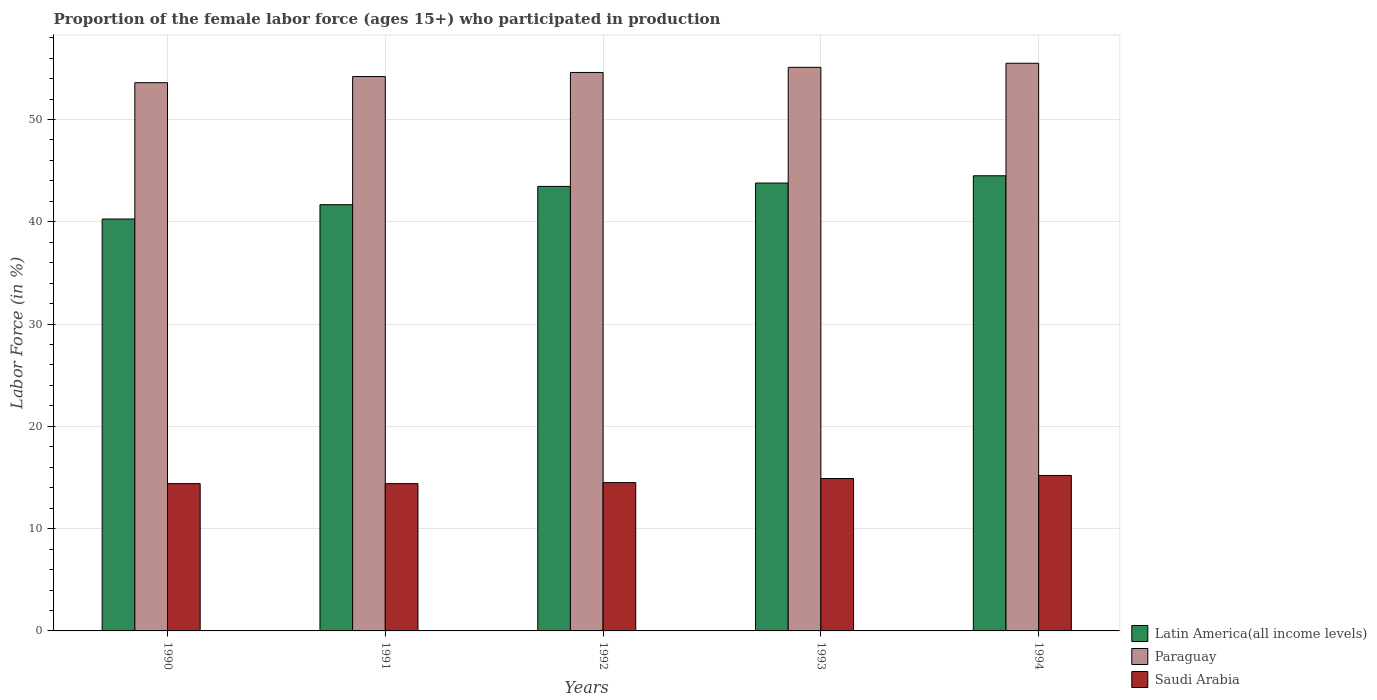How many groups of bars are there?
Provide a succinct answer. 5. Are the number of bars per tick equal to the number of legend labels?
Keep it short and to the point. Yes. Are the number of bars on each tick of the X-axis equal?
Provide a short and direct response. Yes. How many bars are there on the 3rd tick from the left?
Offer a terse response. 3. In how many cases, is the number of bars for a given year not equal to the number of legend labels?
Keep it short and to the point. 0. What is the proportion of the female labor force who participated in production in Latin America(all income levels) in 1991?
Your answer should be very brief. 41.67. Across all years, what is the maximum proportion of the female labor force who participated in production in Latin America(all income levels)?
Provide a short and direct response. 44.5. Across all years, what is the minimum proportion of the female labor force who participated in production in Saudi Arabia?
Ensure brevity in your answer.  14.4. In which year was the proportion of the female labor force who participated in production in Paraguay minimum?
Your answer should be very brief. 1990. What is the total proportion of the female labor force who participated in production in Paraguay in the graph?
Your answer should be compact. 273. What is the difference between the proportion of the female labor force who participated in production in Saudi Arabia in 1992 and the proportion of the female labor force who participated in production in Paraguay in 1991?
Your answer should be very brief. -39.7. What is the average proportion of the female labor force who participated in production in Saudi Arabia per year?
Offer a very short reply. 14.68. In the year 1993, what is the difference between the proportion of the female labor force who participated in production in Latin America(all income levels) and proportion of the female labor force who participated in production in Paraguay?
Give a very brief answer. -11.31. In how many years, is the proportion of the female labor force who participated in production in Paraguay greater than 46 %?
Provide a short and direct response. 5. What is the ratio of the proportion of the female labor force who participated in production in Paraguay in 1990 to that in 1994?
Offer a very short reply. 0.97. What is the difference between the highest and the second highest proportion of the female labor force who participated in production in Paraguay?
Ensure brevity in your answer.  0.4. What is the difference between the highest and the lowest proportion of the female labor force who participated in production in Paraguay?
Give a very brief answer. 1.9. Is the sum of the proportion of the female labor force who participated in production in Latin America(all income levels) in 1992 and 1994 greater than the maximum proportion of the female labor force who participated in production in Paraguay across all years?
Provide a short and direct response. Yes. What does the 1st bar from the left in 1993 represents?
Give a very brief answer. Latin America(all income levels). What does the 1st bar from the right in 1994 represents?
Provide a succinct answer. Saudi Arabia. How many bars are there?
Your answer should be very brief. 15. How many years are there in the graph?
Your response must be concise. 5. What is the difference between two consecutive major ticks on the Y-axis?
Keep it short and to the point. 10. Are the values on the major ticks of Y-axis written in scientific E-notation?
Offer a very short reply. No. Does the graph contain grids?
Offer a very short reply. Yes. Where does the legend appear in the graph?
Your answer should be compact. Bottom right. What is the title of the graph?
Ensure brevity in your answer.  Proportion of the female labor force (ages 15+) who participated in production. Does "United States" appear as one of the legend labels in the graph?
Offer a very short reply. No. What is the Labor Force (in %) of Latin America(all income levels) in 1990?
Ensure brevity in your answer.  40.27. What is the Labor Force (in %) of Paraguay in 1990?
Give a very brief answer. 53.6. What is the Labor Force (in %) in Saudi Arabia in 1990?
Provide a short and direct response. 14.4. What is the Labor Force (in %) of Latin America(all income levels) in 1991?
Your response must be concise. 41.67. What is the Labor Force (in %) in Paraguay in 1991?
Give a very brief answer. 54.2. What is the Labor Force (in %) in Saudi Arabia in 1991?
Your answer should be very brief. 14.4. What is the Labor Force (in %) in Latin America(all income levels) in 1992?
Keep it short and to the point. 43.46. What is the Labor Force (in %) in Paraguay in 1992?
Give a very brief answer. 54.6. What is the Labor Force (in %) of Saudi Arabia in 1992?
Keep it short and to the point. 14.5. What is the Labor Force (in %) in Latin America(all income levels) in 1993?
Keep it short and to the point. 43.79. What is the Labor Force (in %) in Paraguay in 1993?
Your response must be concise. 55.1. What is the Labor Force (in %) in Saudi Arabia in 1993?
Your answer should be compact. 14.9. What is the Labor Force (in %) in Latin America(all income levels) in 1994?
Offer a terse response. 44.5. What is the Labor Force (in %) of Paraguay in 1994?
Provide a succinct answer. 55.5. What is the Labor Force (in %) of Saudi Arabia in 1994?
Provide a succinct answer. 15.2. Across all years, what is the maximum Labor Force (in %) in Latin America(all income levels)?
Offer a terse response. 44.5. Across all years, what is the maximum Labor Force (in %) of Paraguay?
Your response must be concise. 55.5. Across all years, what is the maximum Labor Force (in %) of Saudi Arabia?
Your answer should be compact. 15.2. Across all years, what is the minimum Labor Force (in %) in Latin America(all income levels)?
Provide a succinct answer. 40.27. Across all years, what is the minimum Labor Force (in %) in Paraguay?
Make the answer very short. 53.6. Across all years, what is the minimum Labor Force (in %) of Saudi Arabia?
Your answer should be compact. 14.4. What is the total Labor Force (in %) in Latin America(all income levels) in the graph?
Make the answer very short. 213.69. What is the total Labor Force (in %) in Paraguay in the graph?
Keep it short and to the point. 273. What is the total Labor Force (in %) in Saudi Arabia in the graph?
Ensure brevity in your answer.  73.4. What is the difference between the Labor Force (in %) of Latin America(all income levels) in 1990 and that in 1991?
Make the answer very short. -1.4. What is the difference between the Labor Force (in %) of Latin America(all income levels) in 1990 and that in 1992?
Your answer should be compact. -3.19. What is the difference between the Labor Force (in %) of Paraguay in 1990 and that in 1992?
Your response must be concise. -1. What is the difference between the Labor Force (in %) in Latin America(all income levels) in 1990 and that in 1993?
Make the answer very short. -3.52. What is the difference between the Labor Force (in %) in Paraguay in 1990 and that in 1993?
Keep it short and to the point. -1.5. What is the difference between the Labor Force (in %) in Latin America(all income levels) in 1990 and that in 1994?
Provide a succinct answer. -4.23. What is the difference between the Labor Force (in %) in Latin America(all income levels) in 1991 and that in 1992?
Provide a short and direct response. -1.79. What is the difference between the Labor Force (in %) of Saudi Arabia in 1991 and that in 1992?
Make the answer very short. -0.1. What is the difference between the Labor Force (in %) of Latin America(all income levels) in 1991 and that in 1993?
Your answer should be compact. -2.12. What is the difference between the Labor Force (in %) in Paraguay in 1991 and that in 1993?
Offer a terse response. -0.9. What is the difference between the Labor Force (in %) of Saudi Arabia in 1991 and that in 1993?
Your response must be concise. -0.5. What is the difference between the Labor Force (in %) in Latin America(all income levels) in 1991 and that in 1994?
Provide a succinct answer. -2.83. What is the difference between the Labor Force (in %) of Saudi Arabia in 1991 and that in 1994?
Offer a very short reply. -0.8. What is the difference between the Labor Force (in %) of Latin America(all income levels) in 1992 and that in 1993?
Your response must be concise. -0.33. What is the difference between the Labor Force (in %) in Saudi Arabia in 1992 and that in 1993?
Keep it short and to the point. -0.4. What is the difference between the Labor Force (in %) in Latin America(all income levels) in 1992 and that in 1994?
Your response must be concise. -1.04. What is the difference between the Labor Force (in %) in Paraguay in 1992 and that in 1994?
Your response must be concise. -0.9. What is the difference between the Labor Force (in %) in Saudi Arabia in 1992 and that in 1994?
Keep it short and to the point. -0.7. What is the difference between the Labor Force (in %) of Latin America(all income levels) in 1993 and that in 1994?
Ensure brevity in your answer.  -0.71. What is the difference between the Labor Force (in %) of Paraguay in 1993 and that in 1994?
Give a very brief answer. -0.4. What is the difference between the Labor Force (in %) in Latin America(all income levels) in 1990 and the Labor Force (in %) in Paraguay in 1991?
Keep it short and to the point. -13.93. What is the difference between the Labor Force (in %) in Latin America(all income levels) in 1990 and the Labor Force (in %) in Saudi Arabia in 1991?
Your answer should be compact. 25.87. What is the difference between the Labor Force (in %) in Paraguay in 1990 and the Labor Force (in %) in Saudi Arabia in 1991?
Make the answer very short. 39.2. What is the difference between the Labor Force (in %) of Latin America(all income levels) in 1990 and the Labor Force (in %) of Paraguay in 1992?
Make the answer very short. -14.33. What is the difference between the Labor Force (in %) in Latin America(all income levels) in 1990 and the Labor Force (in %) in Saudi Arabia in 1992?
Ensure brevity in your answer.  25.77. What is the difference between the Labor Force (in %) of Paraguay in 1990 and the Labor Force (in %) of Saudi Arabia in 1992?
Keep it short and to the point. 39.1. What is the difference between the Labor Force (in %) of Latin America(all income levels) in 1990 and the Labor Force (in %) of Paraguay in 1993?
Your response must be concise. -14.83. What is the difference between the Labor Force (in %) of Latin America(all income levels) in 1990 and the Labor Force (in %) of Saudi Arabia in 1993?
Your answer should be compact. 25.37. What is the difference between the Labor Force (in %) of Paraguay in 1990 and the Labor Force (in %) of Saudi Arabia in 1993?
Give a very brief answer. 38.7. What is the difference between the Labor Force (in %) of Latin America(all income levels) in 1990 and the Labor Force (in %) of Paraguay in 1994?
Offer a terse response. -15.23. What is the difference between the Labor Force (in %) of Latin America(all income levels) in 1990 and the Labor Force (in %) of Saudi Arabia in 1994?
Provide a succinct answer. 25.07. What is the difference between the Labor Force (in %) of Paraguay in 1990 and the Labor Force (in %) of Saudi Arabia in 1994?
Offer a very short reply. 38.4. What is the difference between the Labor Force (in %) in Latin America(all income levels) in 1991 and the Labor Force (in %) in Paraguay in 1992?
Give a very brief answer. -12.93. What is the difference between the Labor Force (in %) of Latin America(all income levels) in 1991 and the Labor Force (in %) of Saudi Arabia in 1992?
Offer a terse response. 27.17. What is the difference between the Labor Force (in %) in Paraguay in 1991 and the Labor Force (in %) in Saudi Arabia in 1992?
Keep it short and to the point. 39.7. What is the difference between the Labor Force (in %) in Latin America(all income levels) in 1991 and the Labor Force (in %) in Paraguay in 1993?
Make the answer very short. -13.43. What is the difference between the Labor Force (in %) of Latin America(all income levels) in 1991 and the Labor Force (in %) of Saudi Arabia in 1993?
Keep it short and to the point. 26.77. What is the difference between the Labor Force (in %) of Paraguay in 1991 and the Labor Force (in %) of Saudi Arabia in 1993?
Make the answer very short. 39.3. What is the difference between the Labor Force (in %) of Latin America(all income levels) in 1991 and the Labor Force (in %) of Paraguay in 1994?
Your answer should be compact. -13.83. What is the difference between the Labor Force (in %) in Latin America(all income levels) in 1991 and the Labor Force (in %) in Saudi Arabia in 1994?
Make the answer very short. 26.47. What is the difference between the Labor Force (in %) in Paraguay in 1991 and the Labor Force (in %) in Saudi Arabia in 1994?
Provide a succinct answer. 39. What is the difference between the Labor Force (in %) of Latin America(all income levels) in 1992 and the Labor Force (in %) of Paraguay in 1993?
Make the answer very short. -11.64. What is the difference between the Labor Force (in %) in Latin America(all income levels) in 1992 and the Labor Force (in %) in Saudi Arabia in 1993?
Keep it short and to the point. 28.56. What is the difference between the Labor Force (in %) of Paraguay in 1992 and the Labor Force (in %) of Saudi Arabia in 1993?
Your answer should be compact. 39.7. What is the difference between the Labor Force (in %) of Latin America(all income levels) in 1992 and the Labor Force (in %) of Paraguay in 1994?
Your response must be concise. -12.04. What is the difference between the Labor Force (in %) of Latin America(all income levels) in 1992 and the Labor Force (in %) of Saudi Arabia in 1994?
Offer a terse response. 28.26. What is the difference between the Labor Force (in %) of Paraguay in 1992 and the Labor Force (in %) of Saudi Arabia in 1994?
Keep it short and to the point. 39.4. What is the difference between the Labor Force (in %) of Latin America(all income levels) in 1993 and the Labor Force (in %) of Paraguay in 1994?
Provide a short and direct response. -11.71. What is the difference between the Labor Force (in %) in Latin America(all income levels) in 1993 and the Labor Force (in %) in Saudi Arabia in 1994?
Ensure brevity in your answer.  28.59. What is the difference between the Labor Force (in %) of Paraguay in 1993 and the Labor Force (in %) of Saudi Arabia in 1994?
Ensure brevity in your answer.  39.9. What is the average Labor Force (in %) in Latin America(all income levels) per year?
Provide a succinct answer. 42.74. What is the average Labor Force (in %) of Paraguay per year?
Keep it short and to the point. 54.6. What is the average Labor Force (in %) of Saudi Arabia per year?
Offer a very short reply. 14.68. In the year 1990, what is the difference between the Labor Force (in %) of Latin America(all income levels) and Labor Force (in %) of Paraguay?
Ensure brevity in your answer.  -13.33. In the year 1990, what is the difference between the Labor Force (in %) in Latin America(all income levels) and Labor Force (in %) in Saudi Arabia?
Give a very brief answer. 25.87. In the year 1990, what is the difference between the Labor Force (in %) of Paraguay and Labor Force (in %) of Saudi Arabia?
Offer a terse response. 39.2. In the year 1991, what is the difference between the Labor Force (in %) in Latin America(all income levels) and Labor Force (in %) in Paraguay?
Your answer should be compact. -12.53. In the year 1991, what is the difference between the Labor Force (in %) in Latin America(all income levels) and Labor Force (in %) in Saudi Arabia?
Provide a short and direct response. 27.27. In the year 1991, what is the difference between the Labor Force (in %) of Paraguay and Labor Force (in %) of Saudi Arabia?
Provide a short and direct response. 39.8. In the year 1992, what is the difference between the Labor Force (in %) of Latin America(all income levels) and Labor Force (in %) of Paraguay?
Your answer should be very brief. -11.14. In the year 1992, what is the difference between the Labor Force (in %) in Latin America(all income levels) and Labor Force (in %) in Saudi Arabia?
Offer a very short reply. 28.96. In the year 1992, what is the difference between the Labor Force (in %) in Paraguay and Labor Force (in %) in Saudi Arabia?
Your answer should be very brief. 40.1. In the year 1993, what is the difference between the Labor Force (in %) in Latin America(all income levels) and Labor Force (in %) in Paraguay?
Give a very brief answer. -11.31. In the year 1993, what is the difference between the Labor Force (in %) in Latin America(all income levels) and Labor Force (in %) in Saudi Arabia?
Your answer should be very brief. 28.89. In the year 1993, what is the difference between the Labor Force (in %) of Paraguay and Labor Force (in %) of Saudi Arabia?
Your response must be concise. 40.2. In the year 1994, what is the difference between the Labor Force (in %) of Latin America(all income levels) and Labor Force (in %) of Paraguay?
Offer a terse response. -11. In the year 1994, what is the difference between the Labor Force (in %) in Latin America(all income levels) and Labor Force (in %) in Saudi Arabia?
Provide a short and direct response. 29.3. In the year 1994, what is the difference between the Labor Force (in %) in Paraguay and Labor Force (in %) in Saudi Arabia?
Offer a very short reply. 40.3. What is the ratio of the Labor Force (in %) of Latin America(all income levels) in 1990 to that in 1991?
Ensure brevity in your answer.  0.97. What is the ratio of the Labor Force (in %) in Paraguay in 1990 to that in 1991?
Your response must be concise. 0.99. What is the ratio of the Labor Force (in %) in Latin America(all income levels) in 1990 to that in 1992?
Your answer should be very brief. 0.93. What is the ratio of the Labor Force (in %) in Paraguay in 1990 to that in 1992?
Give a very brief answer. 0.98. What is the ratio of the Labor Force (in %) in Saudi Arabia in 1990 to that in 1992?
Your response must be concise. 0.99. What is the ratio of the Labor Force (in %) of Latin America(all income levels) in 1990 to that in 1993?
Your answer should be compact. 0.92. What is the ratio of the Labor Force (in %) of Paraguay in 1990 to that in 1993?
Provide a succinct answer. 0.97. What is the ratio of the Labor Force (in %) of Saudi Arabia in 1990 to that in 1993?
Ensure brevity in your answer.  0.97. What is the ratio of the Labor Force (in %) in Latin America(all income levels) in 1990 to that in 1994?
Your answer should be very brief. 0.91. What is the ratio of the Labor Force (in %) in Paraguay in 1990 to that in 1994?
Your answer should be compact. 0.97. What is the ratio of the Labor Force (in %) of Latin America(all income levels) in 1991 to that in 1992?
Provide a succinct answer. 0.96. What is the ratio of the Labor Force (in %) in Paraguay in 1991 to that in 1992?
Your answer should be very brief. 0.99. What is the ratio of the Labor Force (in %) of Latin America(all income levels) in 1991 to that in 1993?
Offer a terse response. 0.95. What is the ratio of the Labor Force (in %) in Paraguay in 1991 to that in 1993?
Keep it short and to the point. 0.98. What is the ratio of the Labor Force (in %) of Saudi Arabia in 1991 to that in 1993?
Give a very brief answer. 0.97. What is the ratio of the Labor Force (in %) of Latin America(all income levels) in 1991 to that in 1994?
Provide a succinct answer. 0.94. What is the ratio of the Labor Force (in %) in Paraguay in 1991 to that in 1994?
Your answer should be compact. 0.98. What is the ratio of the Labor Force (in %) in Saudi Arabia in 1991 to that in 1994?
Your answer should be very brief. 0.95. What is the ratio of the Labor Force (in %) in Paraguay in 1992 to that in 1993?
Provide a short and direct response. 0.99. What is the ratio of the Labor Force (in %) in Saudi Arabia in 1992 to that in 1993?
Make the answer very short. 0.97. What is the ratio of the Labor Force (in %) of Latin America(all income levels) in 1992 to that in 1994?
Provide a succinct answer. 0.98. What is the ratio of the Labor Force (in %) of Paraguay in 1992 to that in 1994?
Your answer should be very brief. 0.98. What is the ratio of the Labor Force (in %) of Saudi Arabia in 1992 to that in 1994?
Provide a succinct answer. 0.95. What is the ratio of the Labor Force (in %) in Latin America(all income levels) in 1993 to that in 1994?
Offer a terse response. 0.98. What is the ratio of the Labor Force (in %) of Paraguay in 1993 to that in 1994?
Ensure brevity in your answer.  0.99. What is the ratio of the Labor Force (in %) of Saudi Arabia in 1993 to that in 1994?
Offer a very short reply. 0.98. What is the difference between the highest and the second highest Labor Force (in %) in Latin America(all income levels)?
Your response must be concise. 0.71. What is the difference between the highest and the second highest Labor Force (in %) in Paraguay?
Your answer should be compact. 0.4. What is the difference between the highest and the second highest Labor Force (in %) of Saudi Arabia?
Provide a succinct answer. 0.3. What is the difference between the highest and the lowest Labor Force (in %) in Latin America(all income levels)?
Offer a terse response. 4.23. 